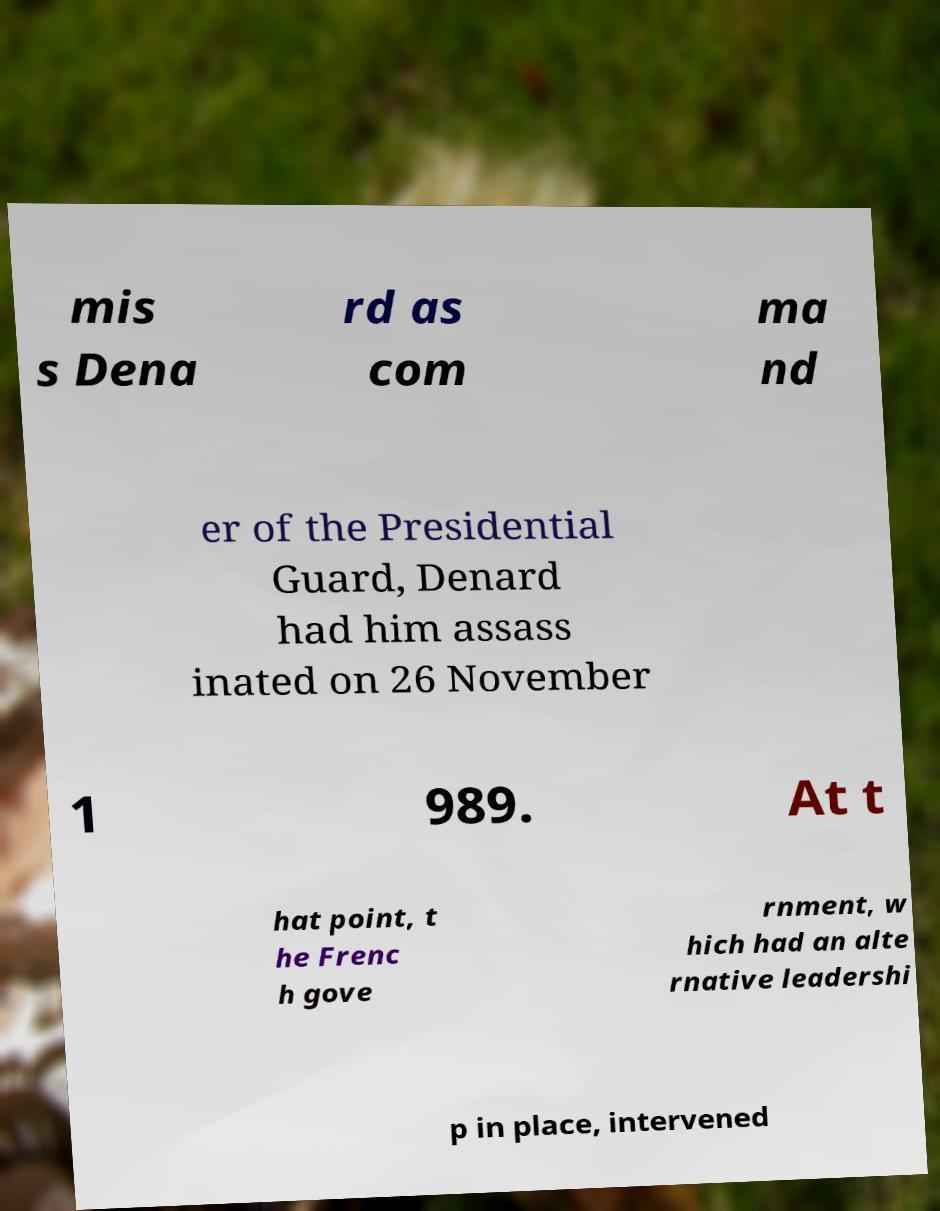For documentation purposes, I need the text within this image transcribed. Could you provide that? mis s Dena rd as com ma nd er of the Presidential Guard, Denard had him assass inated on 26 November 1 989. At t hat point, t he Frenc h gove rnment, w hich had an alte rnative leadershi p in place, intervened 